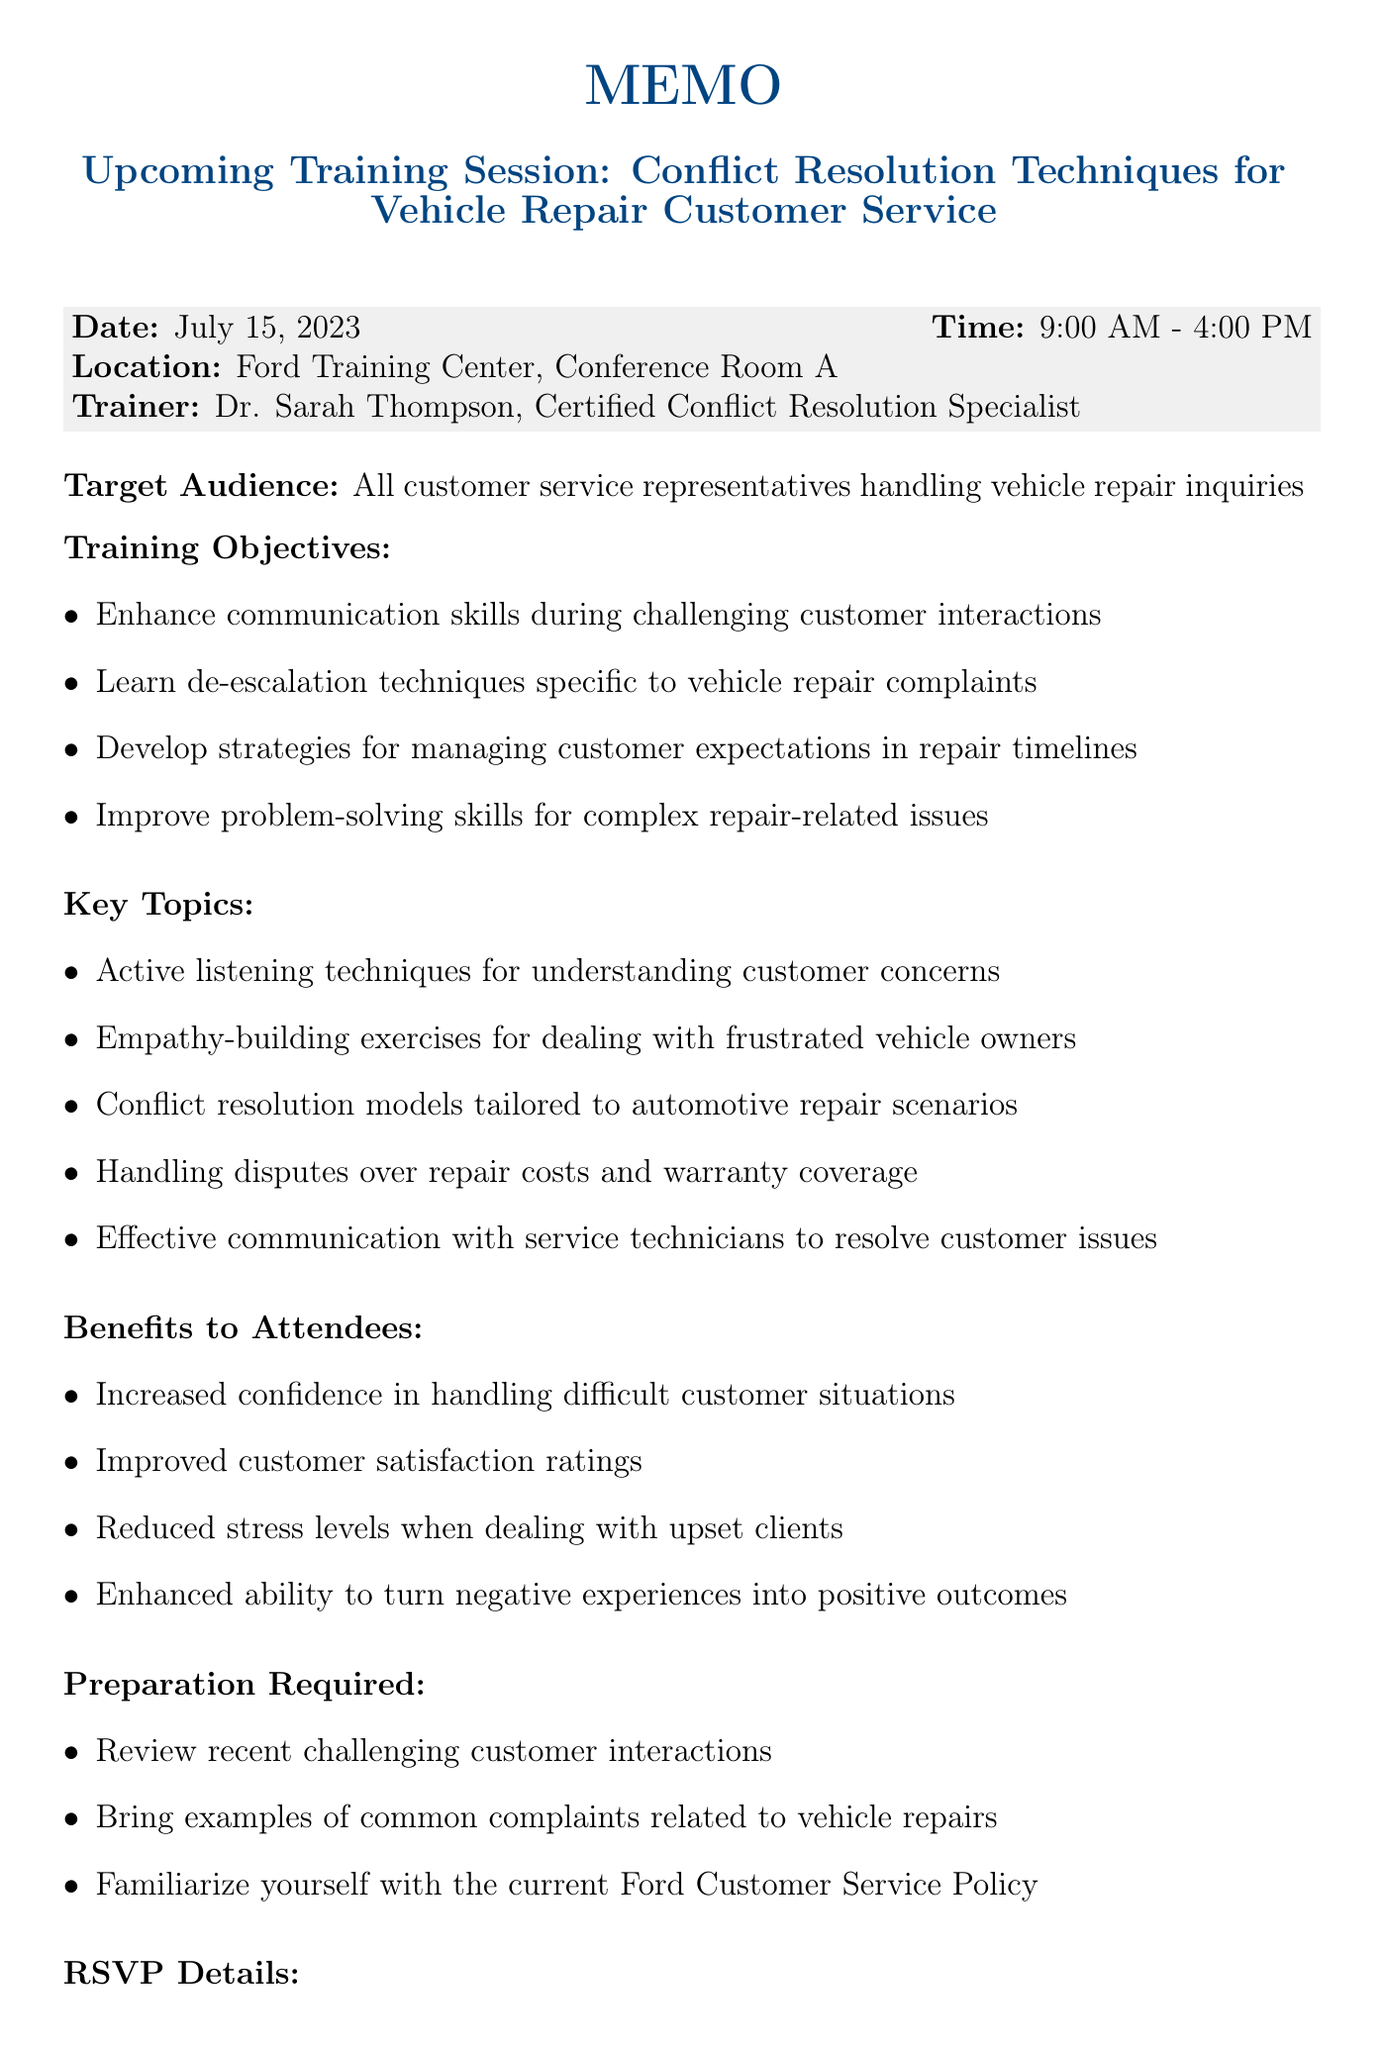What is the date of the training session? The date of the training session is listed in the document as the day it will take place.
Answer: July 15, 2023 Who is the trainer for the session? The name of the trainer is provided in the document as the person leading the session.
Answer: Dr. Sarah Thompson, Certified Conflict Resolution Specialist What are the training objectives related to communication? The document lists multiple objectives, one of which pertains to improving communication skills.
Answer: Enhance communication skills during challenging customer interactions What time does the training session start? The document mentions a specific starting time for the training session.
Answer: 9:00 AM What is the RSVP deadline for the training session? The document specifies a deadline for participants to confirm their attendance.
Answer: July 8, 2023 What is one of the benefits to attendees? The document outlines several benefits attendees will gain from the training session.
Answer: Increased confidence in handling difficult customer situations What should attendees bring to the training? The document states a requirement for participants regarding what they need to bring along.
Answer: Examples of common complaints related to vehicle repairs What location is the training session held in? The document identifies the venue for the training session.
Answer: Ford Training Center, Conference Room A 